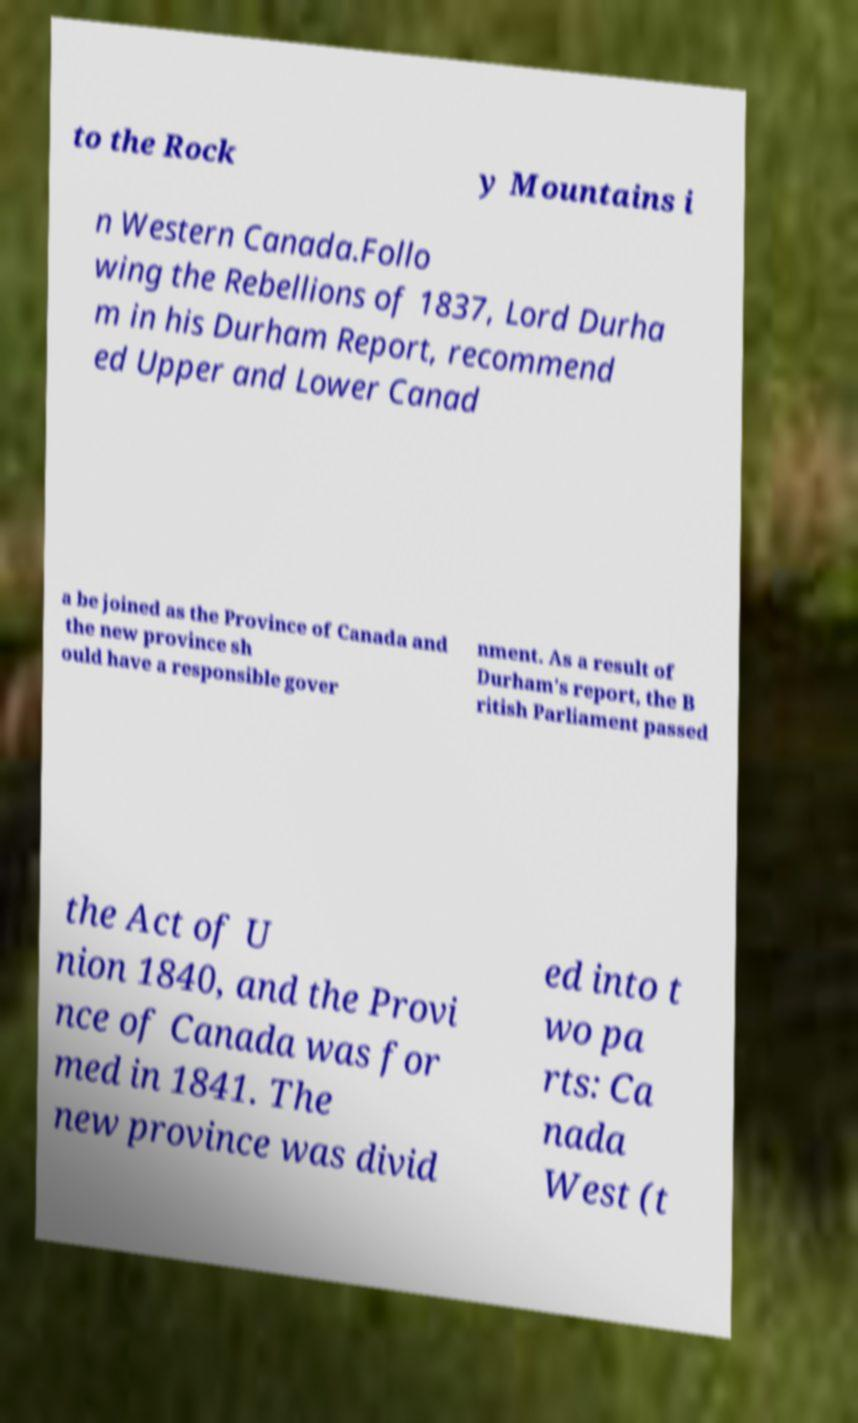For documentation purposes, I need the text within this image transcribed. Could you provide that? to the Rock y Mountains i n Western Canada.Follo wing the Rebellions of 1837, Lord Durha m in his Durham Report, recommend ed Upper and Lower Canad a be joined as the Province of Canada and the new province sh ould have a responsible gover nment. As a result of Durham's report, the B ritish Parliament passed the Act of U nion 1840, and the Provi nce of Canada was for med in 1841. The new province was divid ed into t wo pa rts: Ca nada West (t 